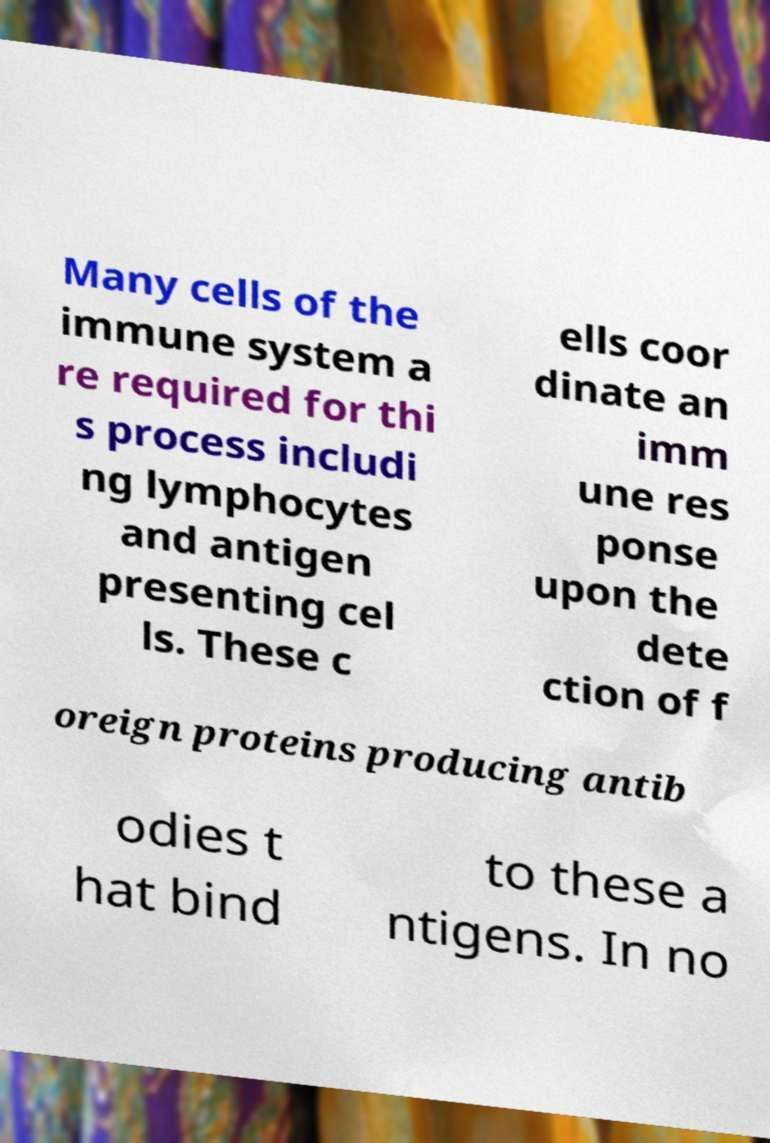I need the written content from this picture converted into text. Can you do that? Many cells of the immune system a re required for thi s process includi ng lymphocytes and antigen presenting cel ls. These c ells coor dinate an imm une res ponse upon the dete ction of f oreign proteins producing antib odies t hat bind to these a ntigens. In no 